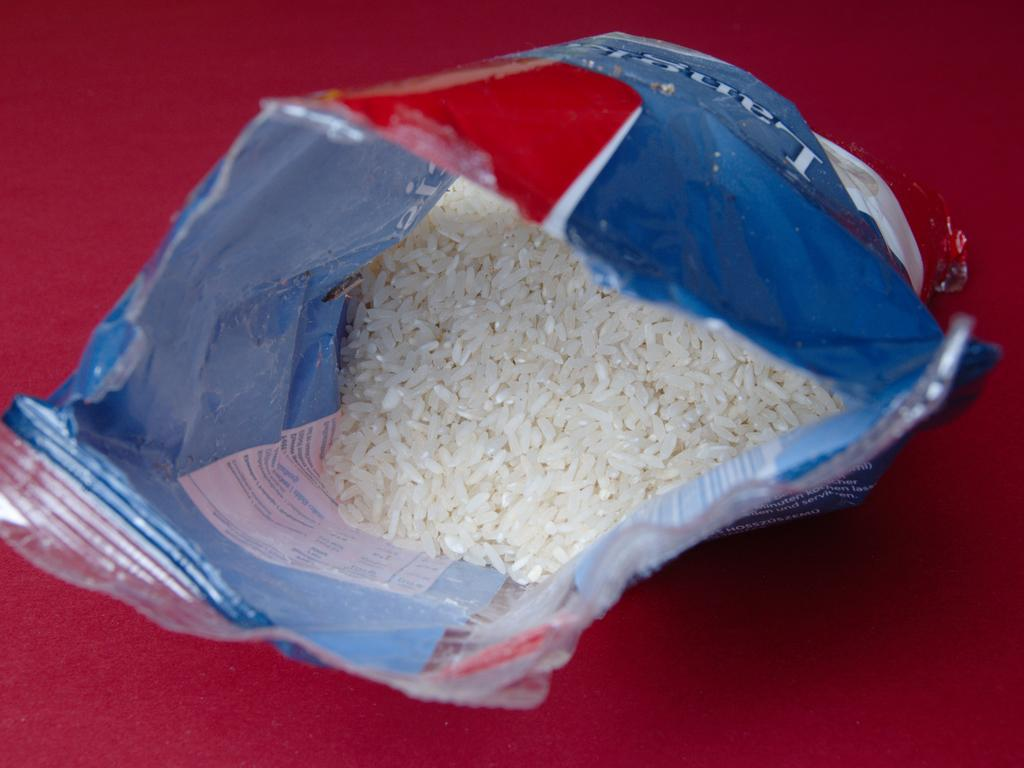What is the main object in the image? There is a packet of rice in the image. What is the color of the surface on which the packet of rice is placed? The packet of rice is placed on a red-colored surface. Is there a crown visible on the packet of rice in the image? No, there is no crown present on the packet of rice in the image. 